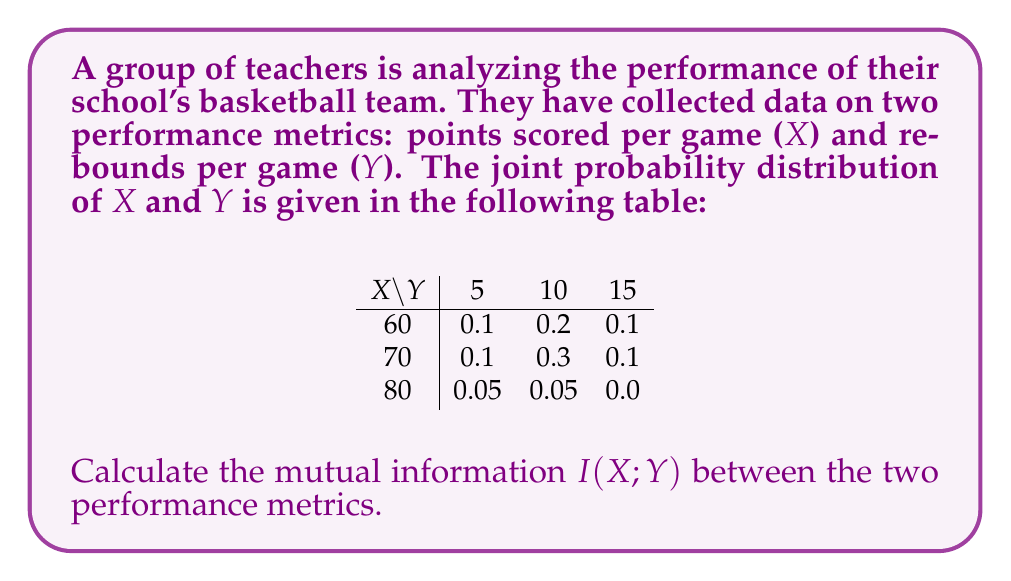What is the answer to this math problem? To calculate the mutual information $I(X;Y)$, we'll follow these steps:

1) First, we need to calculate the marginal probabilities $P(X)$ and $P(Y)$:

   $P(X=60) = 0.1 + 0.2 + 0.1 = 0.4$
   $P(X=70) = 0.1 + 0.3 + 0.1 = 0.5$
   $P(X=80) = 0.05 + 0.05 + 0.0 = 0.1$

   $P(Y=5) = 0.1 + 0.1 + 0.05 = 0.25$
   $P(Y=10) = 0.2 + 0.3 + 0.05 = 0.55$
   $P(Y=15) = 0.1 + 0.1 + 0.0 = 0.2$

2) The mutual information is given by:

   $$I(X;Y) = \sum_{x,y} P(x,y) \log_2 \frac{P(x,y)}{P(x)P(y)}$$

3) Let's calculate each term:

   For $X=60, Y=5$: $0.1 \log_2 \frac{0.1}{0.4 \cdot 0.25} = 0.1 \log_2 1 = 0$
   For $X=60, Y=10$: $0.2 \log_2 \frac{0.2}{0.4 \cdot 0.55} \approx 0.0344$
   For $X=60, Y=15$: $0.1 \log_2 \frac{0.1}{0.4 \cdot 0.2} \approx 0.0614$
   For $X=70, Y=5$: $0.1 \log_2 \frac{0.1}{0.5 \cdot 0.25} \approx 0.0214$
   For $X=70, Y=10$: $0.3 \log_2 \frac{0.3}{0.5 \cdot 0.55} \approx 0.0449$
   For $X=70, Y=15$: $0.1 \log_2 \frac{0.1}{0.5 \cdot 0.2} \approx 0.0214$
   For $X=80, Y=5$: $0.05 \log_2 \frac{0.05}{0.1 \cdot 0.25} \approx 0.0432$
   For $X=80, Y=10$: $0.05 \log_2 \frac{0.05}{0.1 \cdot 0.55} \approx 0.0214$
   For $X=80, Y=15$: $0 \log_2 \frac{0}{0.1 \cdot 0.2} = 0$

4) Sum all these terms:

   $I(X;Y) \approx 0 + 0.0344 + 0.0614 + 0.0214 + 0.0449 + 0.0214 + 0.0432 + 0.0214 + 0 \approx 0.2481$ bits
Answer: The mutual information $I(X;Y)$ between points scored per game and rebounds per game is approximately 0.2481 bits. 